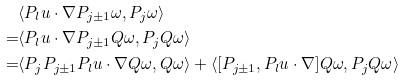<formula> <loc_0><loc_0><loc_500><loc_500>& \langle P _ { l } u \cdot \nabla P _ { j \pm 1 } \omega , P _ { j } \omega \rangle \\ = & \langle P _ { l } u \cdot \nabla P _ { j \pm 1 } Q \omega , P _ { j } Q \omega \rangle \\ = & \langle P _ { j } P _ { j \pm 1 } P _ { l } u \cdot \nabla Q \omega , Q \omega \rangle + \langle [ P _ { j \pm 1 } , P _ { l } u \cdot \nabla ] Q \omega , P _ { j } Q \omega \rangle</formula> 